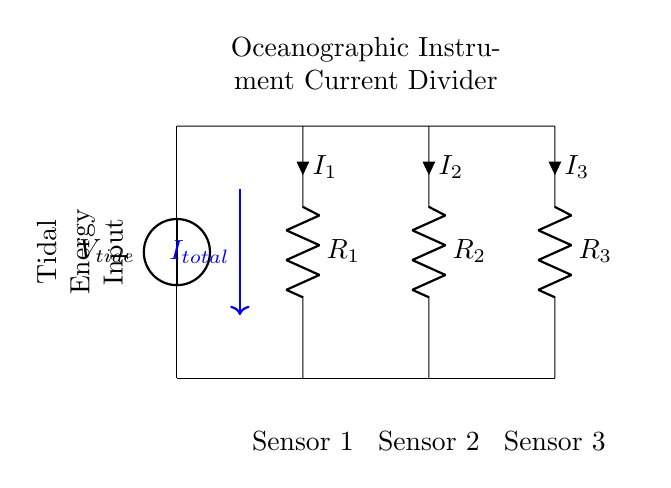What is the total current flowing into the current divider? The total current is indicated on the diagram as I total, shown with an arrow pointing down from the voltage source. This is the current supplied by the tidal energy input.
Answer: I total How many resistors are present in this circuit? The circuit diagram shows three resistors arranged in parallel (R1, R2, and R3). Each one plays a crucial role in dividing the current based on their resistance values.
Answer: 3 What do the resistors represent in this context? The resistors in the circuit represent the sensors used to measure various oceanographic parameters. Each resistor corresponds to one specific sensor in the tidal energy harvesting system.
Answer: Sensors What is the relationship between the resistances and the current divisions? The current division is executed based on the resistances of each resistor: the ratio of the currents through the resistors inversely correlates with their resistance values following the formula, where lower resistance allows more current to flow through that path.
Answer: Inversely; lower resistance, higher current What is the role of the tidal energy input in the circuit? The tidal energy input serves as the voltage source that drives the current through the resistors, allowing the oceanographic instruments to operate effectively, driven by the energy harvested from tidal movements.
Answer: Voltage source How does increasing resistance in the current divider affect sensor performance? Increasing the resistance of a specific sensor (resistor) would decrease the current flowing to that sensor, potentially impacting its performance by reducing the amount of power it receives from the tidal energy source.
Answer: Decreases current to sensor 